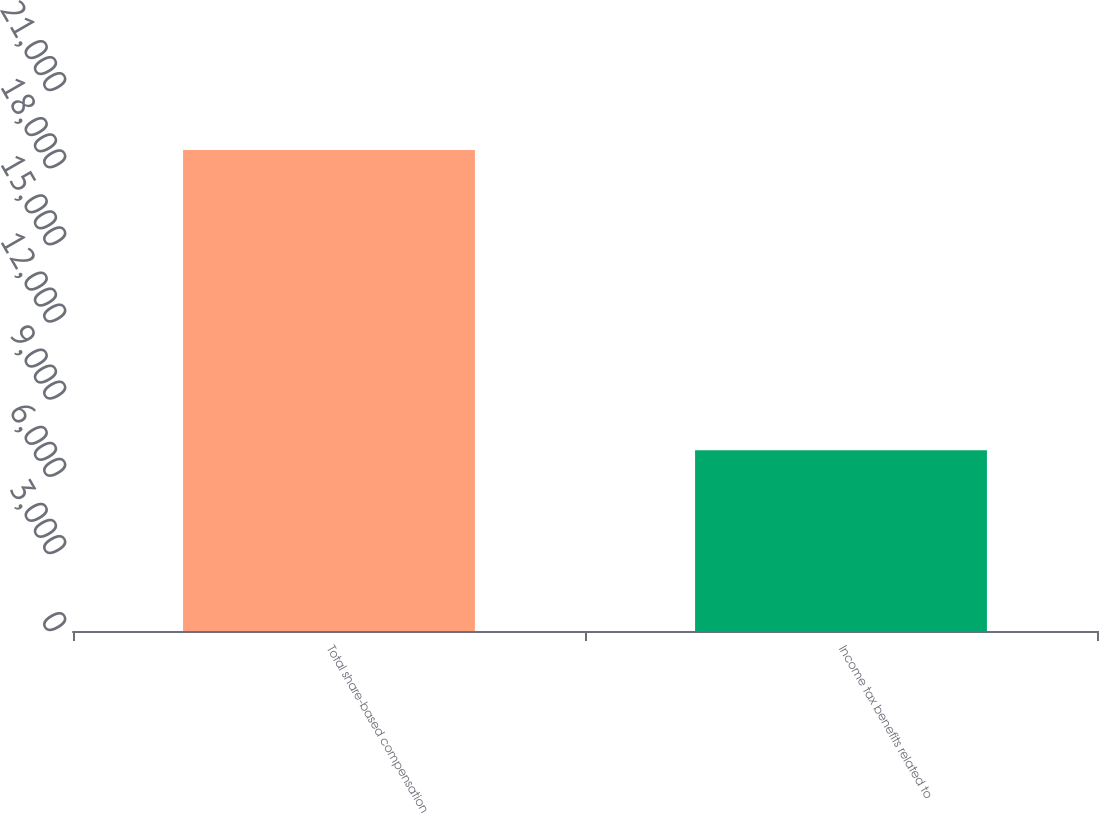<chart> <loc_0><loc_0><loc_500><loc_500><bar_chart><fcel>Total share-based compensation<fcel>Income tax benefits related to<nl><fcel>18707<fcel>7025<nl></chart> 